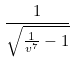<formula> <loc_0><loc_0><loc_500><loc_500>\frac { 1 } { \sqrt { \frac { 1 } { v ^ { 7 } } - 1 } }</formula> 